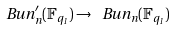<formula> <loc_0><loc_0><loc_500><loc_500>\ B u n ^ { \prime } _ { n } ( { \mathbb { F } } _ { q _ { 1 } } ) \to \ B u n _ { n } ( { \mathbb { F } } _ { q _ { 1 } } )</formula> 